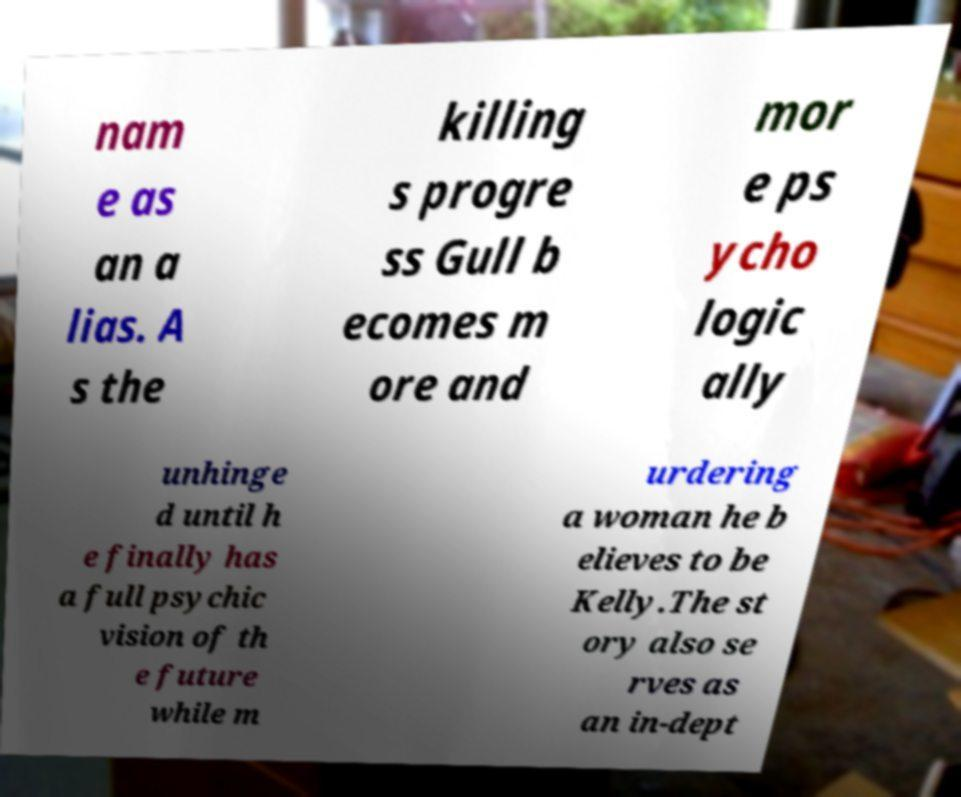What messages or text are displayed in this image? I need them in a readable, typed format. nam e as an a lias. A s the killing s progre ss Gull b ecomes m ore and mor e ps ycho logic ally unhinge d until h e finally has a full psychic vision of th e future while m urdering a woman he b elieves to be Kelly.The st ory also se rves as an in-dept 